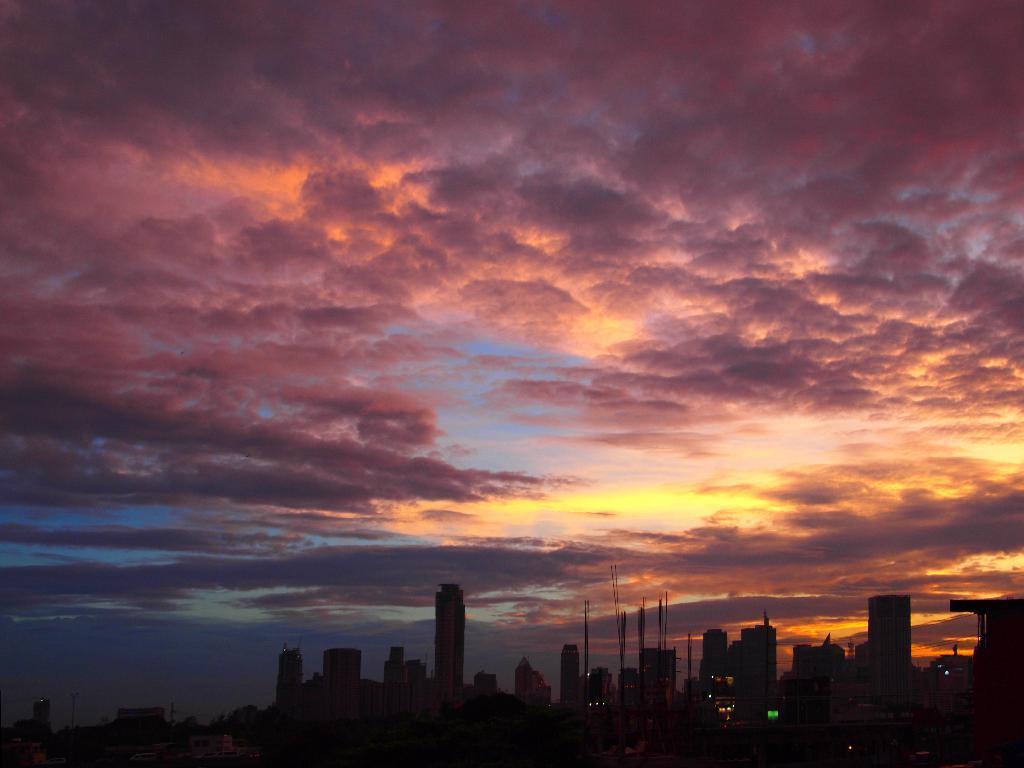Describe this image in one or two sentences. In this image, I see lot of buildings over here and above that I see the sky which is in reddish in color. 